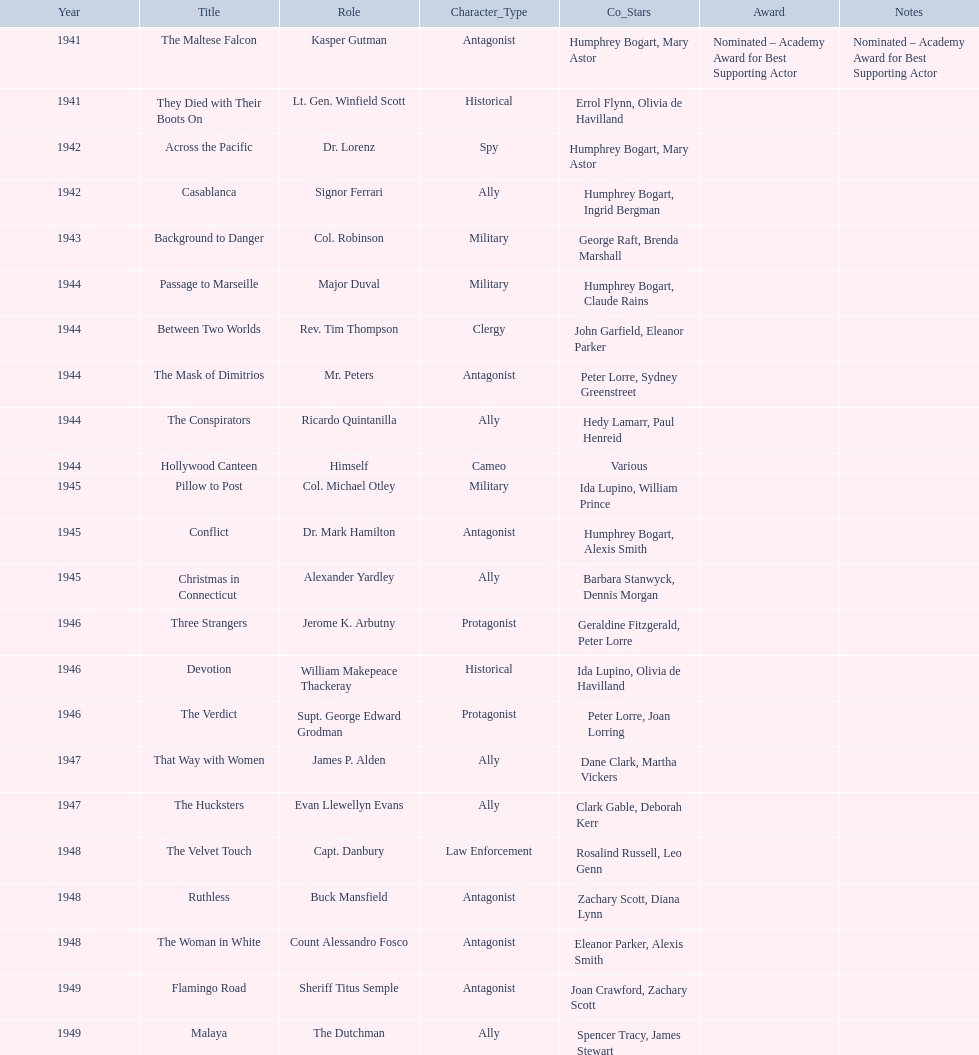What year was the movie that was nominated ? 1941. What was the title of the movie? The Maltese Falcon. 